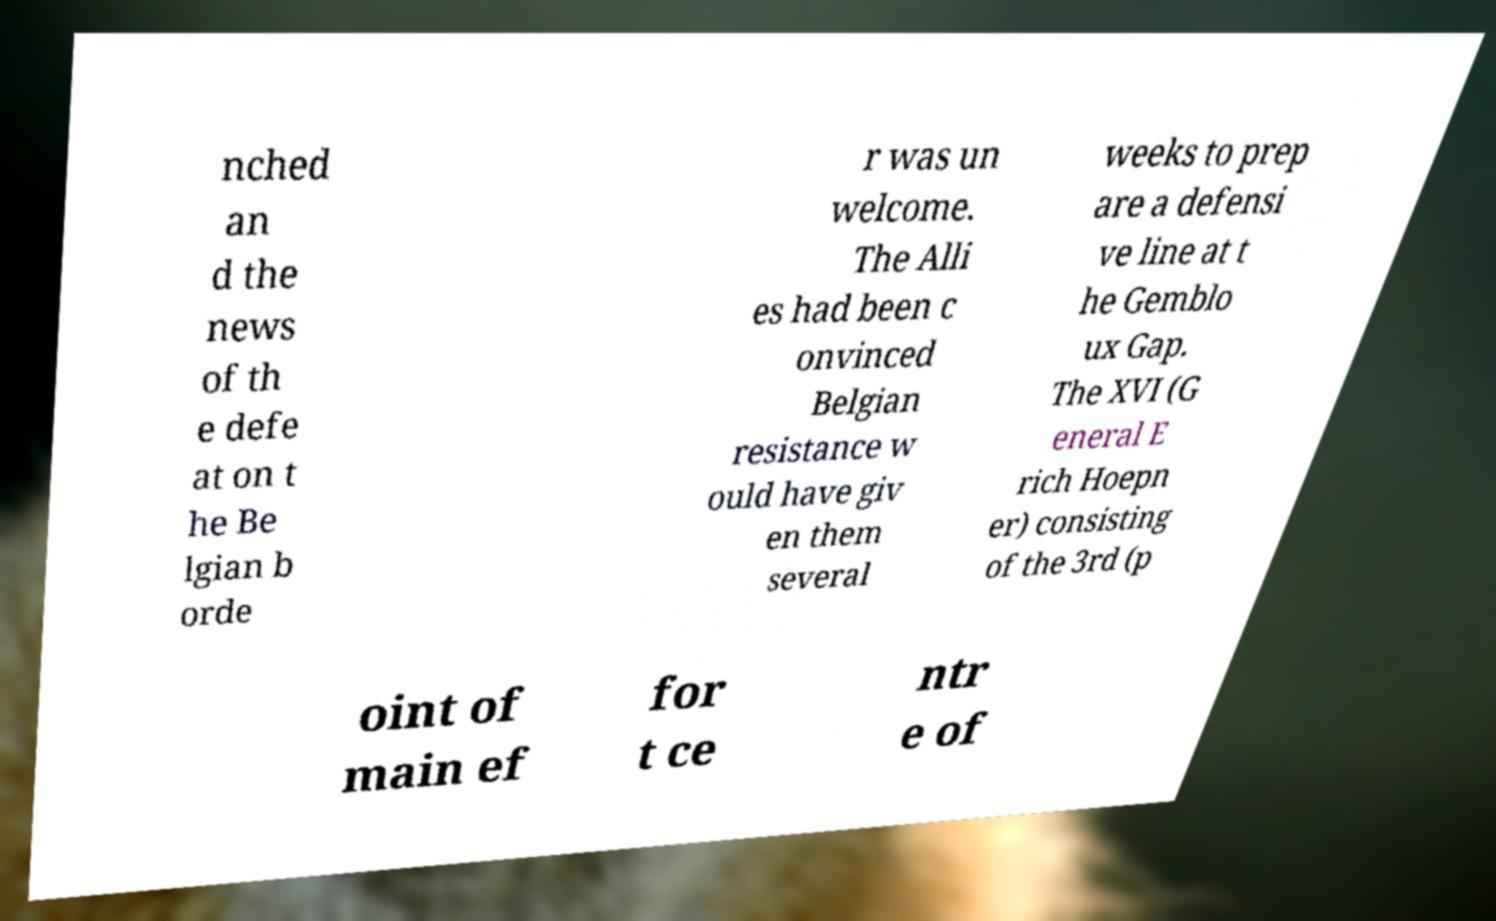Could you assist in decoding the text presented in this image and type it out clearly? nched an d the news of th e defe at on t he Be lgian b orde r was un welcome. The Alli es had been c onvinced Belgian resistance w ould have giv en them several weeks to prep are a defensi ve line at t he Gemblo ux Gap. The XVI (G eneral E rich Hoepn er) consisting of the 3rd (p oint of main ef for t ce ntr e of 